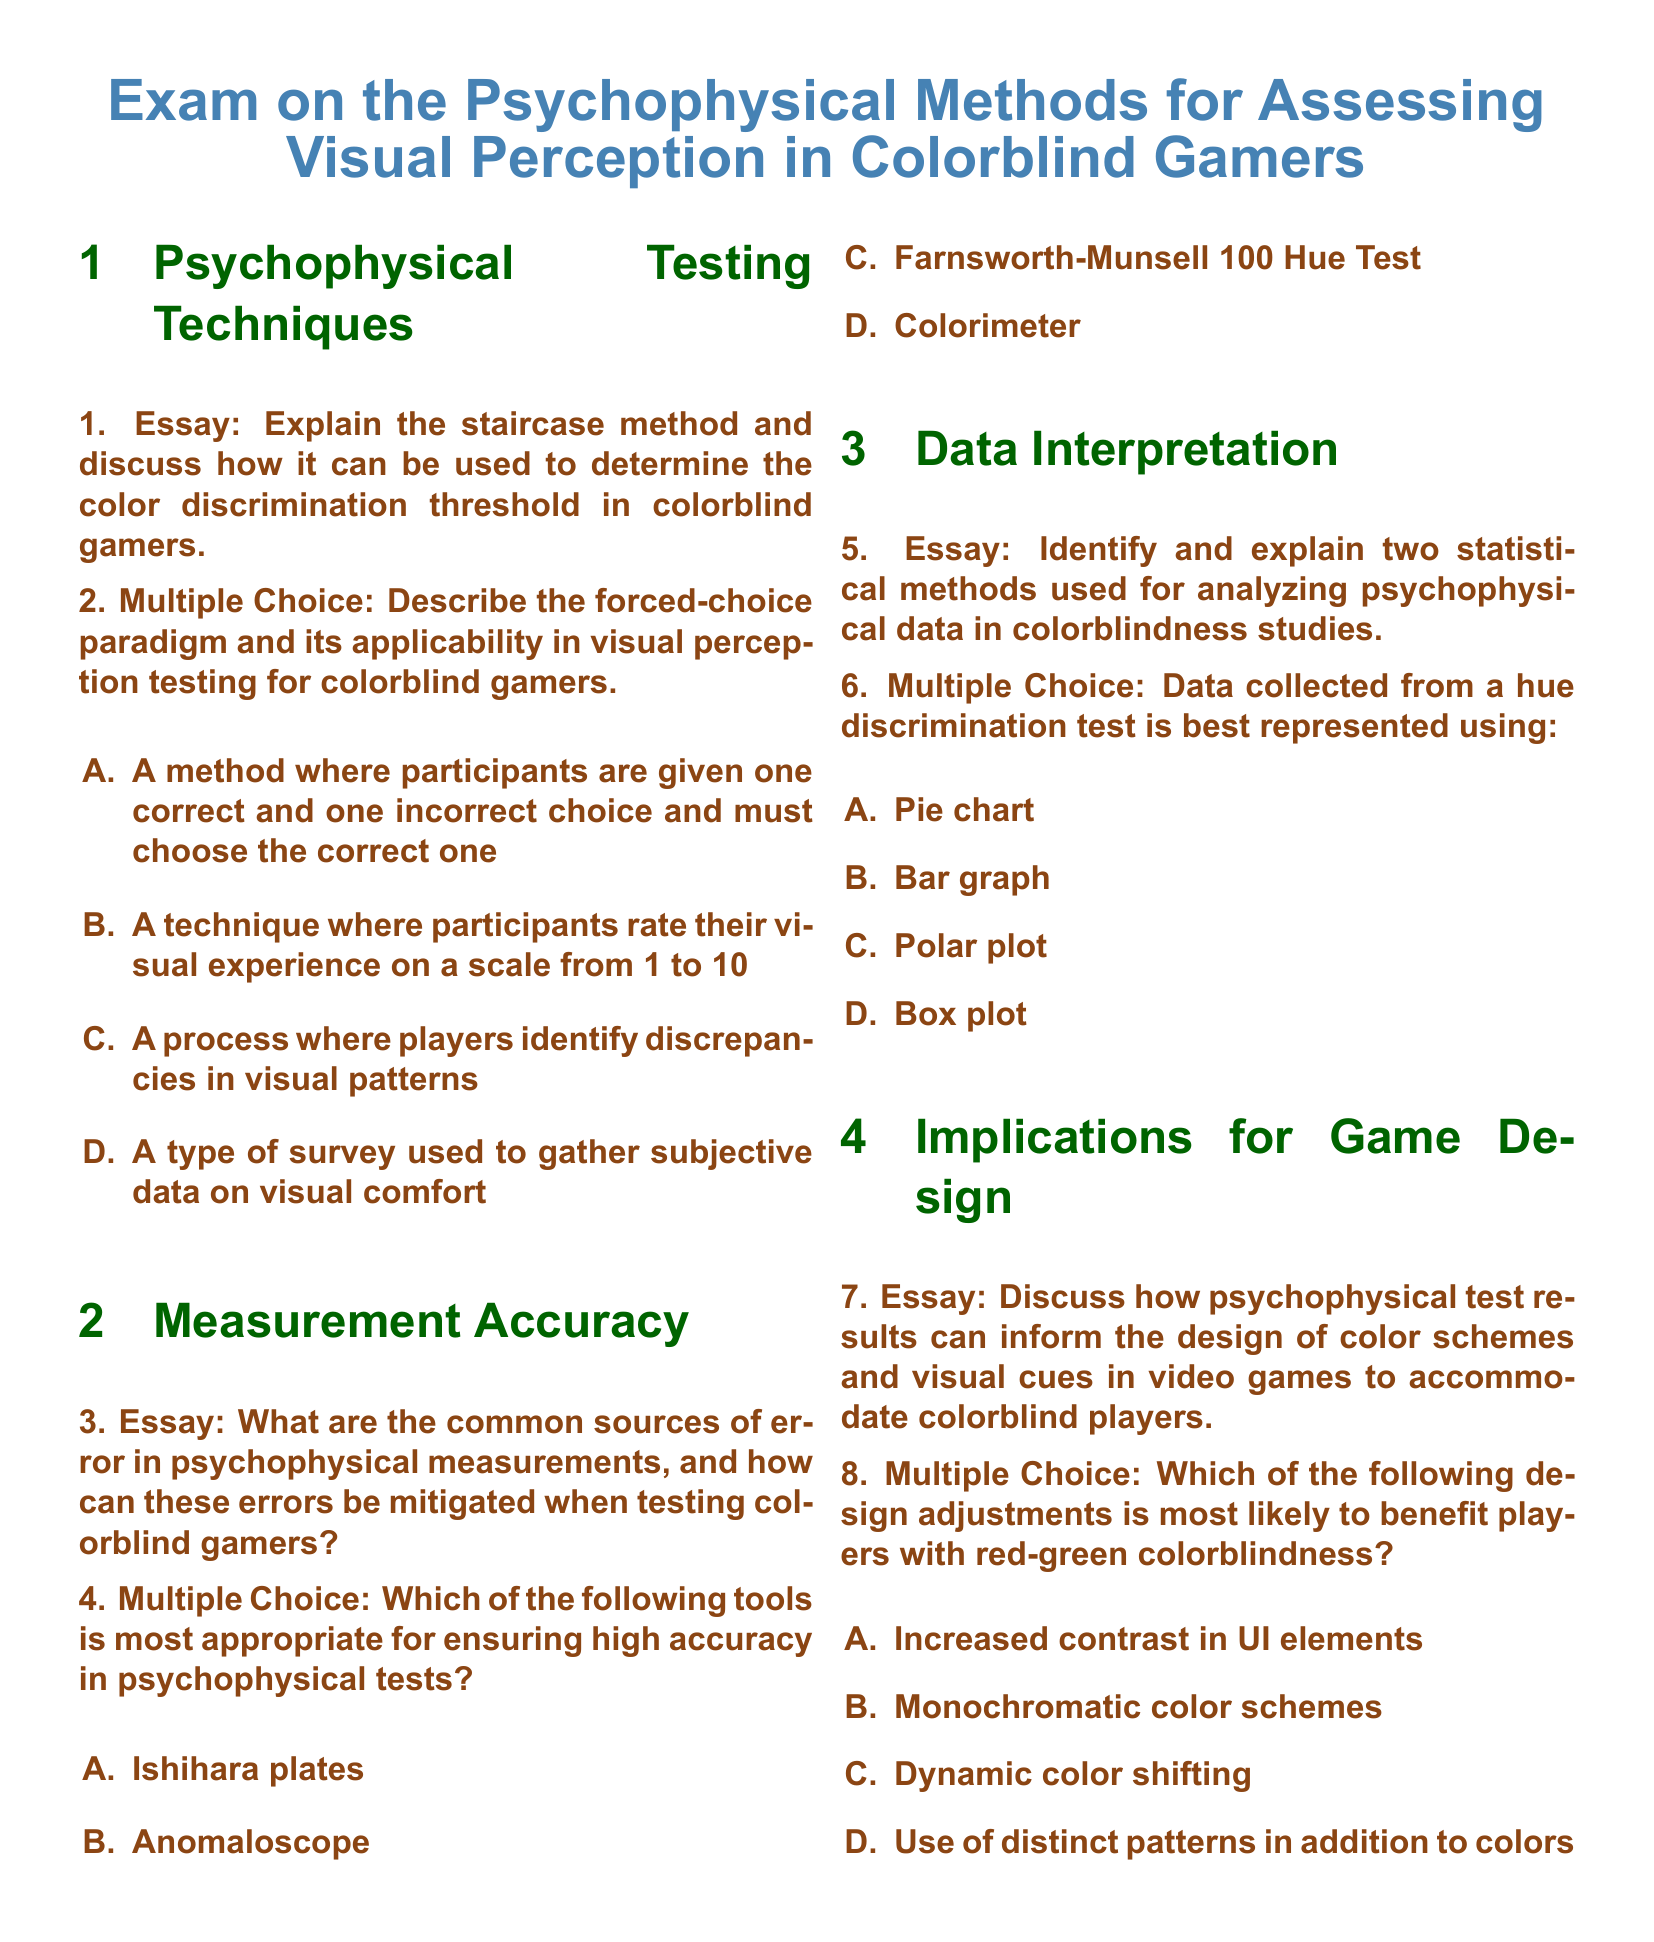What is the title of the exam? The title of the exam as stated in the document is the main header and indicates the subject matter.
Answer: Exam on the Psychophysical Methods for Assessing Visual Perception in Colorblind Gamers What is the first psychophysical testing technique mentioned? The document lists specific questions related to psychophysical testing techniques, starting with the staircase method.
Answer: Staircase method How many multiple choice questions are included in the document? The document presents a total of four multiple choice questions interspersed among essay questions.
Answer: Four What does the forced-choice paradigm involve? The document specifies that the forced-choice paradigm is a method where participants must choose the correct option from the choices given.
Answer: A method where participants are given one correct and one incorrect choice and must choose the correct one Which tool is most appropriate for accurate psychophysical tests? The document lists the options for a multiple choice question about the tools used, with one being particularly noted as appropriate for accuracy.
Answer: Anomaloscope How many sections are in the exam document? The exam document is organized into distinct sections, each covering a specific area of study related to the topic.
Answer: Four What adjustment will likely benefit players with red-green colorblindness? The document outlines a specific design adjustment as beneficial for players with this condition, categorized in one of the multiple choice questions.
Answer: Increased contrast in UI elements What types of questions are included in the exam? The exam consists of essay questions and multiple-choice questions, reflecting different methods of assessment.
Answer: Essay and multiple choice 